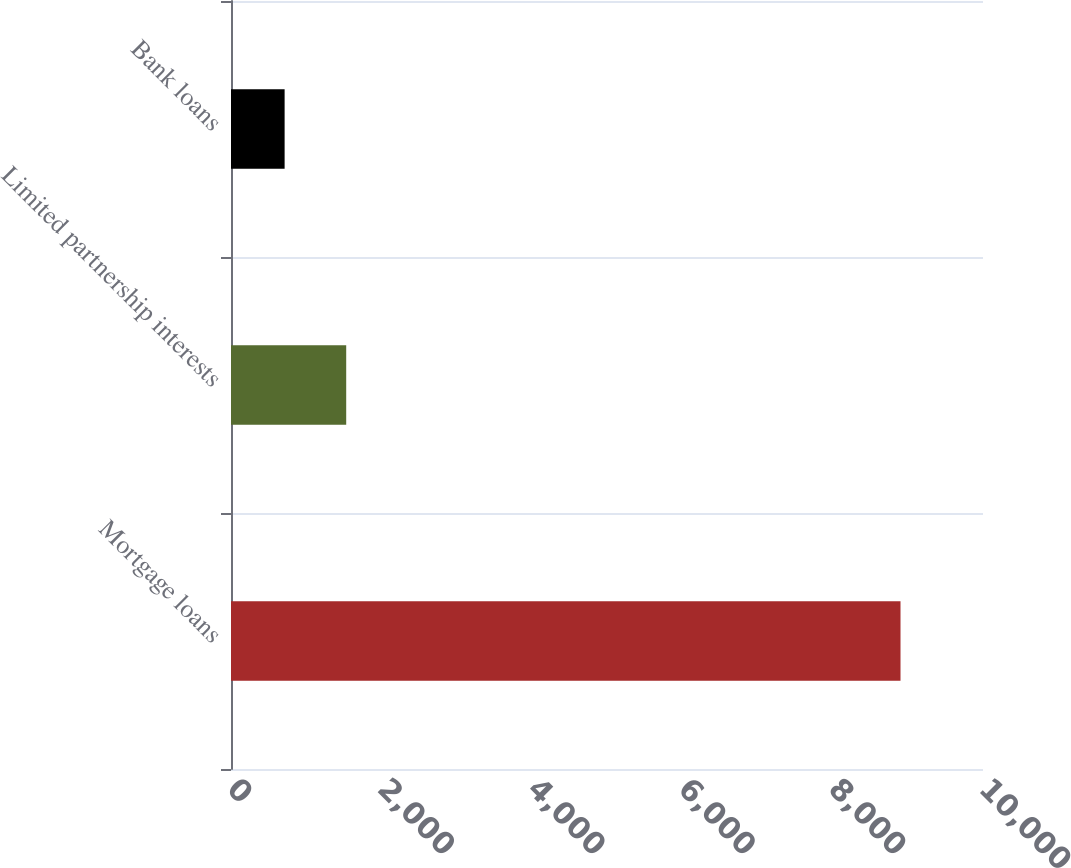<chart> <loc_0><loc_0><loc_500><loc_500><bar_chart><fcel>Mortgage loans<fcel>Limited partnership interests<fcel>Bank loans<nl><fcel>8903<fcel>1532<fcel>713<nl></chart> 